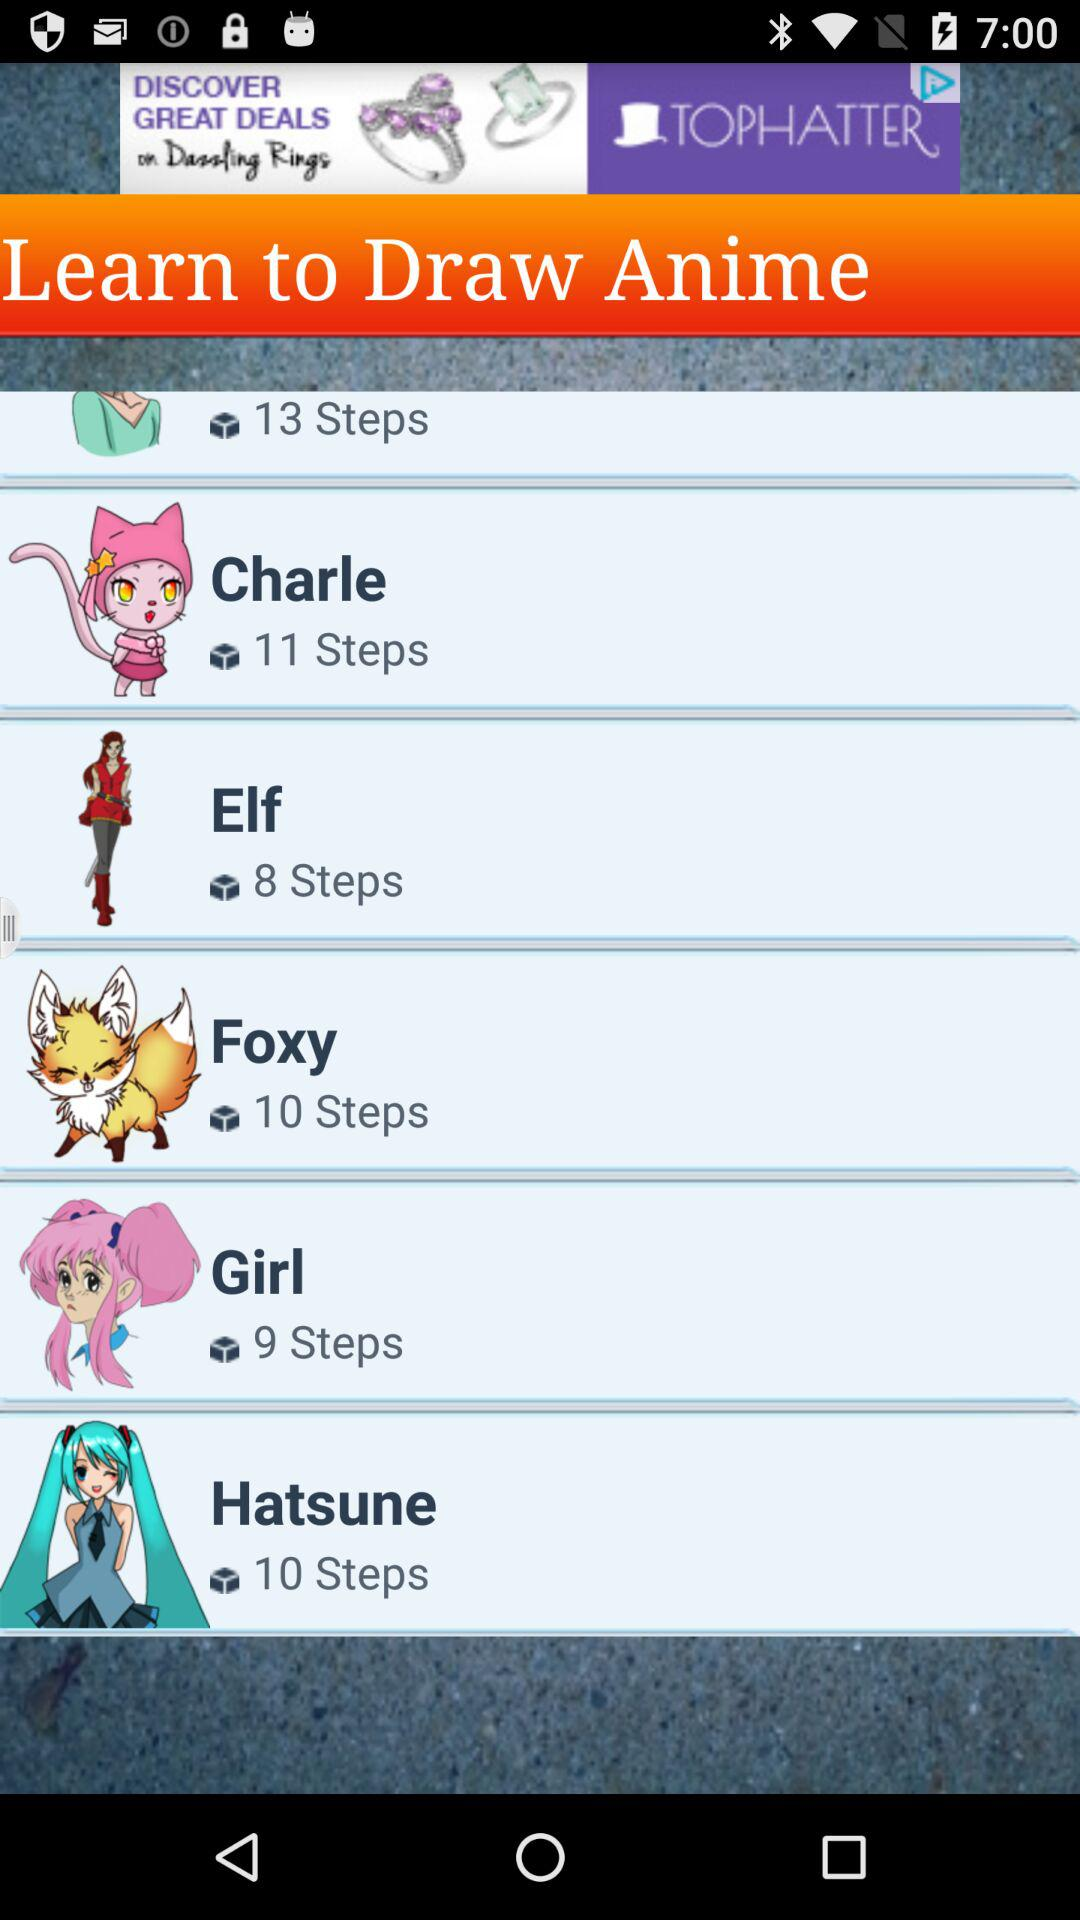What is the name of the anime having 9 steps? The name of the anime is "Girl". 